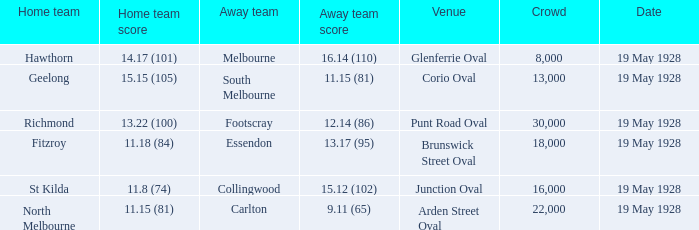What was the reported attendance at junction oval? 16000.0. 